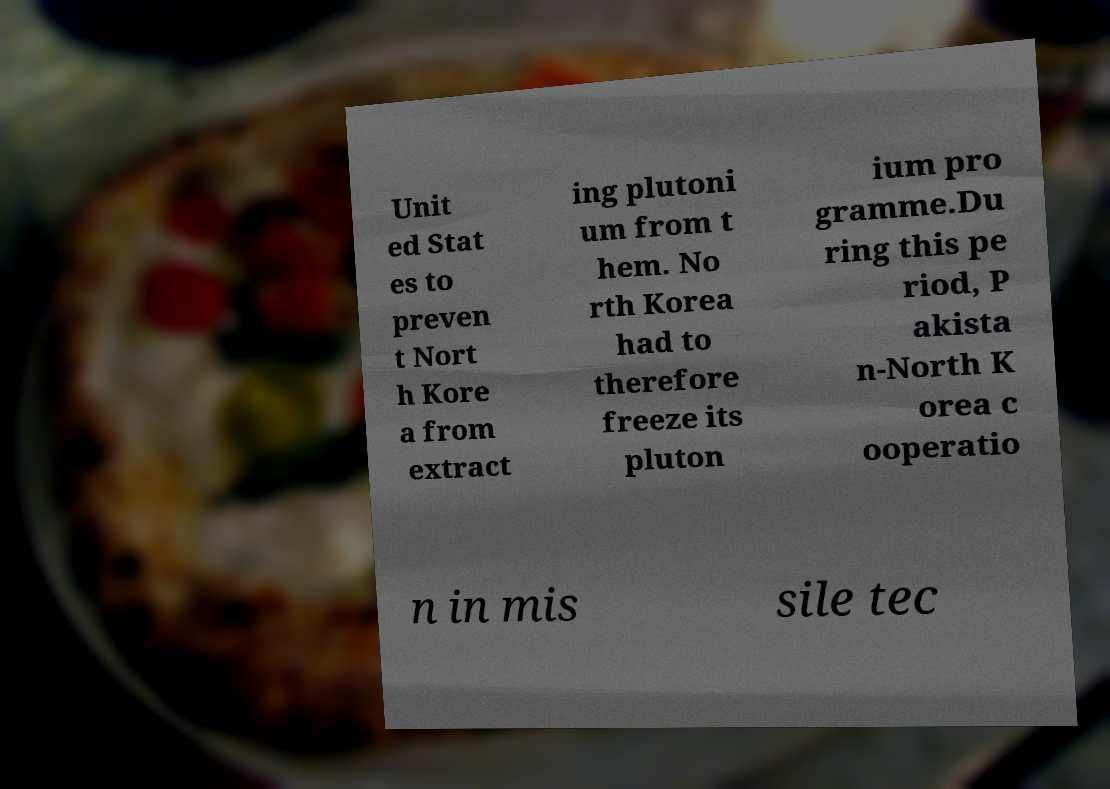There's text embedded in this image that I need extracted. Can you transcribe it verbatim? Unit ed Stat es to preven t Nort h Kore a from extract ing plutoni um from t hem. No rth Korea had to therefore freeze its pluton ium pro gramme.Du ring this pe riod, P akista n-North K orea c ooperatio n in mis sile tec 